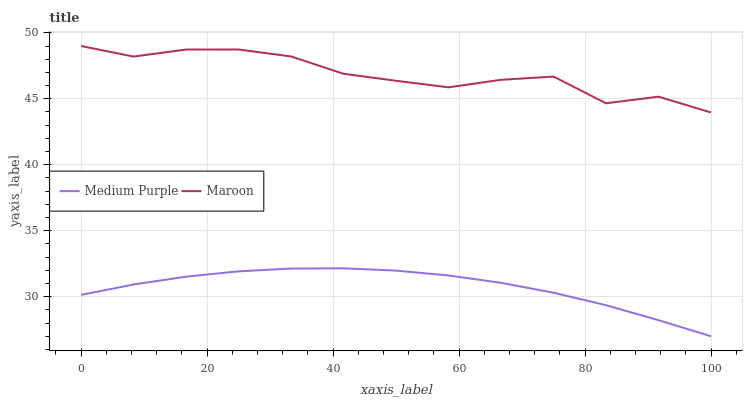Does Medium Purple have the minimum area under the curve?
Answer yes or no. Yes. Does Maroon have the maximum area under the curve?
Answer yes or no. Yes. Does Maroon have the minimum area under the curve?
Answer yes or no. No. Is Medium Purple the smoothest?
Answer yes or no. Yes. Is Maroon the roughest?
Answer yes or no. Yes. Is Maroon the smoothest?
Answer yes or no. No. Does Maroon have the lowest value?
Answer yes or no. No. Does Maroon have the highest value?
Answer yes or no. Yes. Is Medium Purple less than Maroon?
Answer yes or no. Yes. Is Maroon greater than Medium Purple?
Answer yes or no. Yes. Does Medium Purple intersect Maroon?
Answer yes or no. No. 